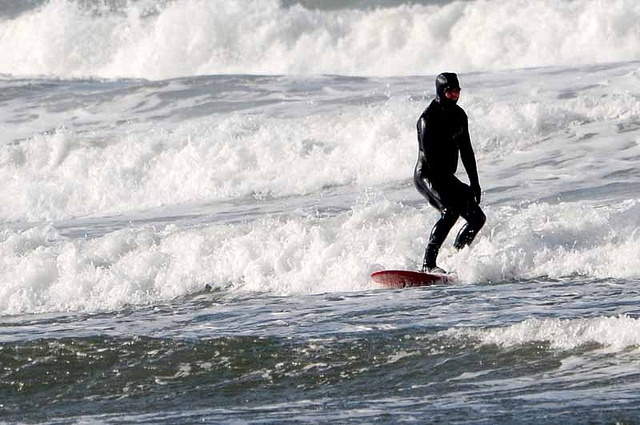Describe the objects in this image and their specific colors. I can see people in gray, black, lightgray, and darkgray tones and surfboard in gray, black, maroon, and brown tones in this image. 